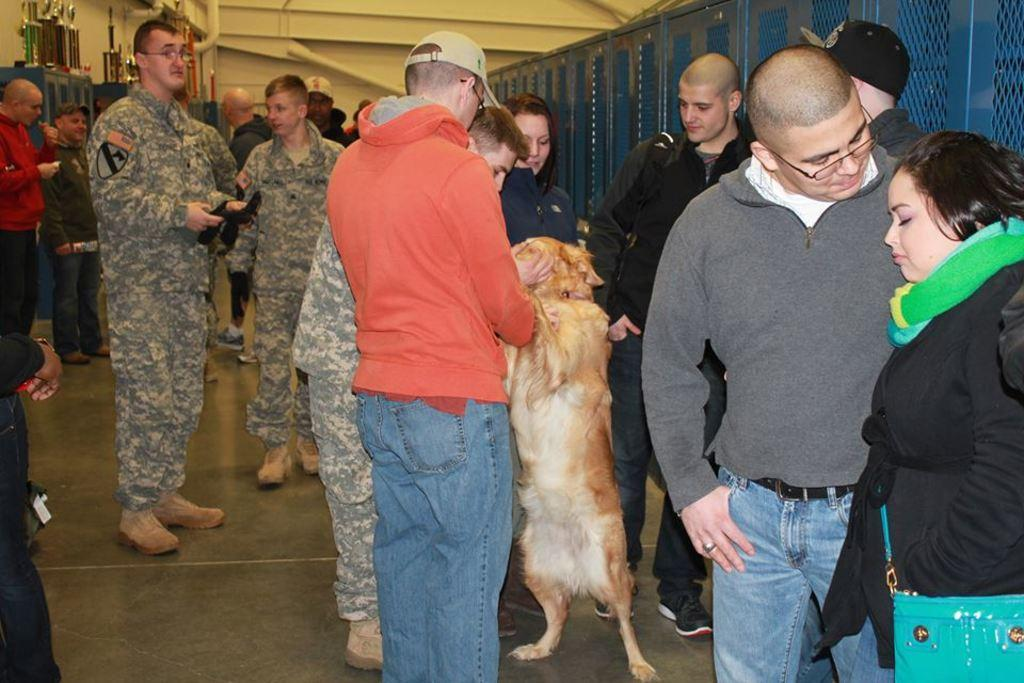How many people are in the image? There is a group of people in the image. What is one person doing with an animal in the image? A person is holding a dog in the image. What type of scissors are being used by the person answering questions in the image? There is no person answering questions or using scissors in the image. 